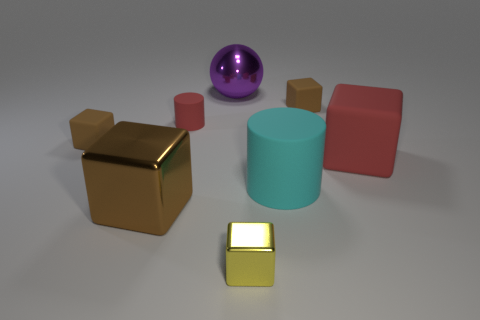What is the size of the red cube?
Offer a terse response. Large. What is the material of the red object that is the same size as the purple ball?
Your answer should be compact. Rubber. There is a matte cylinder that is behind the large cyan matte object; how big is it?
Your answer should be compact. Small. There is a red matte thing to the right of the big sphere; is it the same size as the cylinder to the right of the metallic ball?
Provide a succinct answer. Yes. What number of large purple objects have the same material as the small red cylinder?
Your response must be concise. 0. The large cylinder is what color?
Provide a succinct answer. Cyan. There is a cyan thing; are there any red matte cylinders in front of it?
Provide a succinct answer. No. Do the tiny rubber cylinder and the large matte cube have the same color?
Make the answer very short. Yes. How many metallic balls are the same color as the small cylinder?
Provide a short and direct response. 0. What is the size of the metallic block that is on the left side of the red matte thing that is on the left side of the large red thing?
Offer a very short reply. Large. 